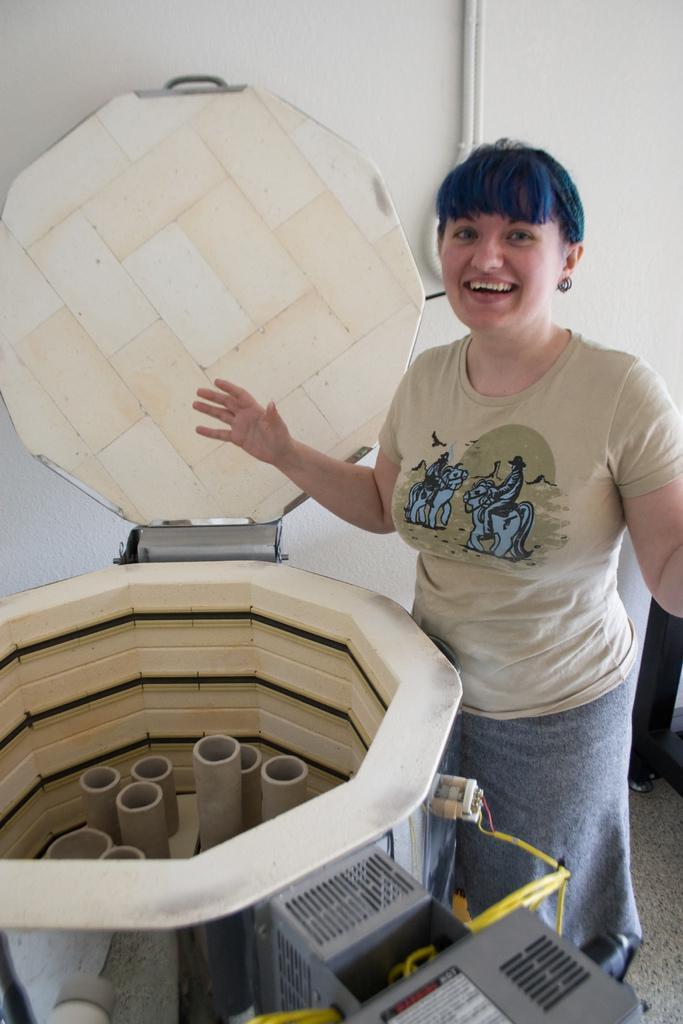Can you describe this image briefly? In this image I can see the person with the dress. In-front of the person I can see the machine and I can see the white wall in the back. 